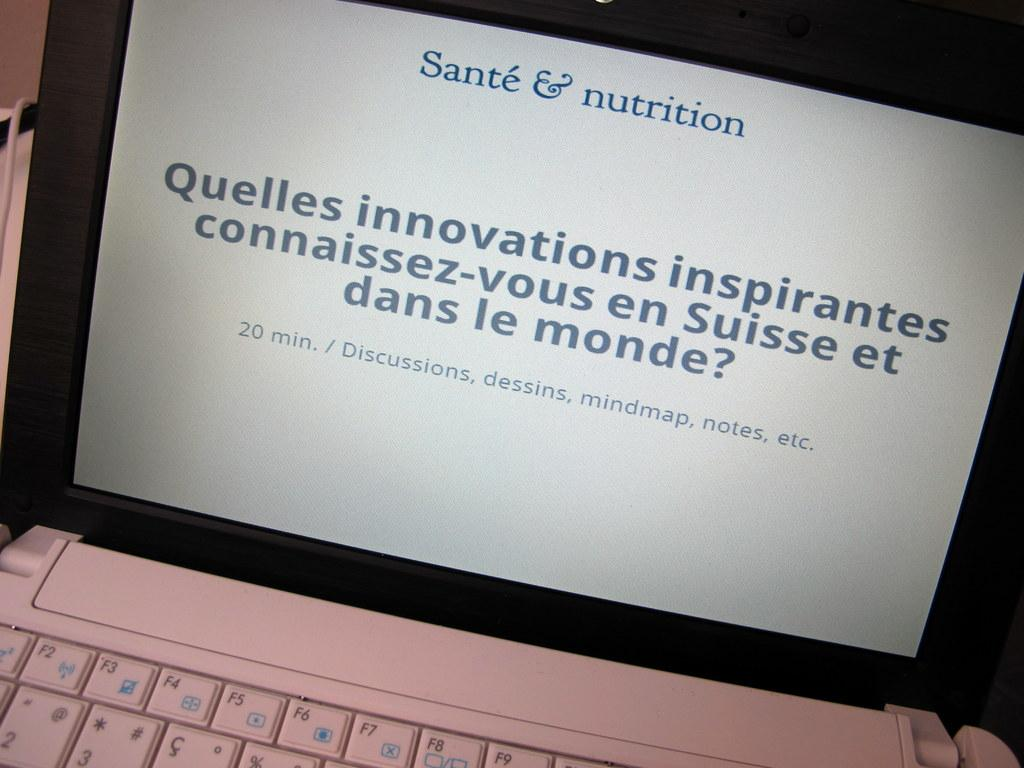<image>
Give a short and clear explanation of the subsequent image. Person using a computer with the name "Sante & Nutrition" on the top. 